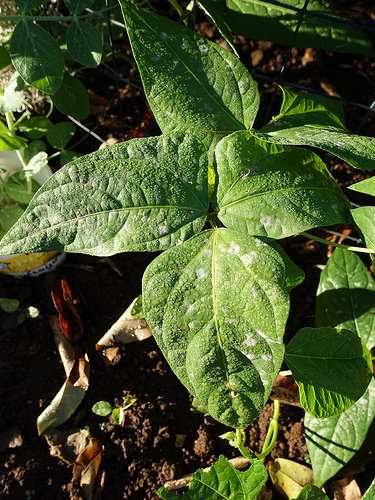<image>
Can you confirm if the leaf is on the ground? No. The leaf is not positioned on the ground. They may be near each other, but the leaf is not supported by or resting on top of the ground. 